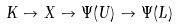Convert formula to latex. <formula><loc_0><loc_0><loc_500><loc_500>K \to X \to \Psi ( U ) \to \Psi ( L )</formula> 